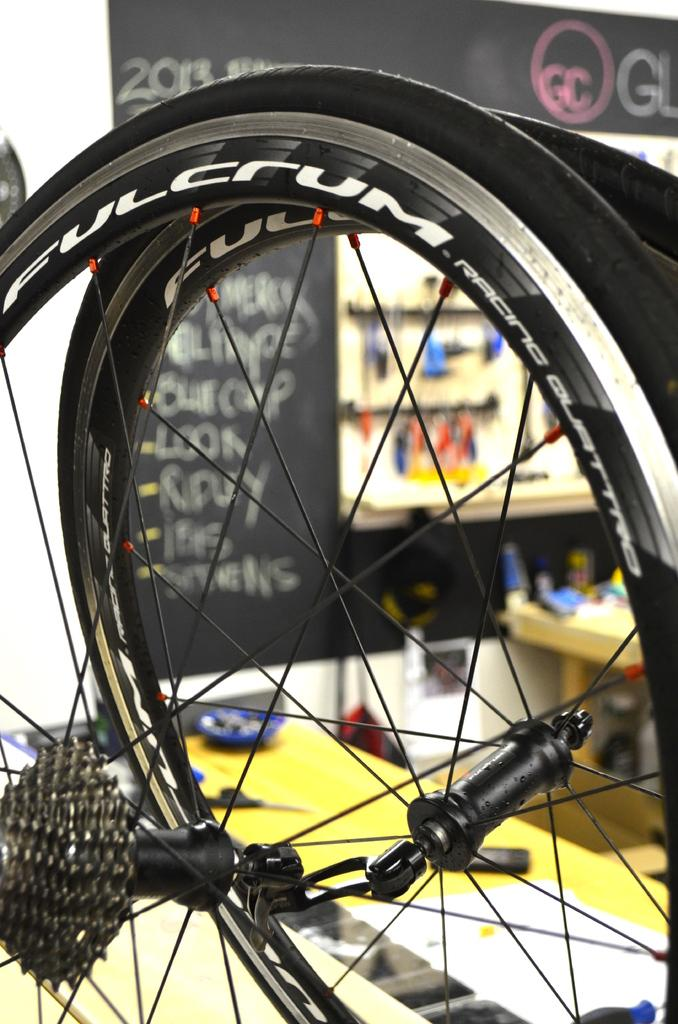What is the main object in the image? There is a wheel in the image. What can be seen in the background of the image? There are tables, a poster, and other objects in the background of the image. How does the wheel contribute to the digestion process in the image? The wheel does not contribute to any digestion process in the image, as it is an inanimate object. 